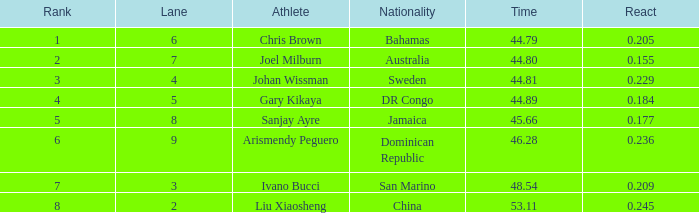How many entire time listings possess a 0.0. 